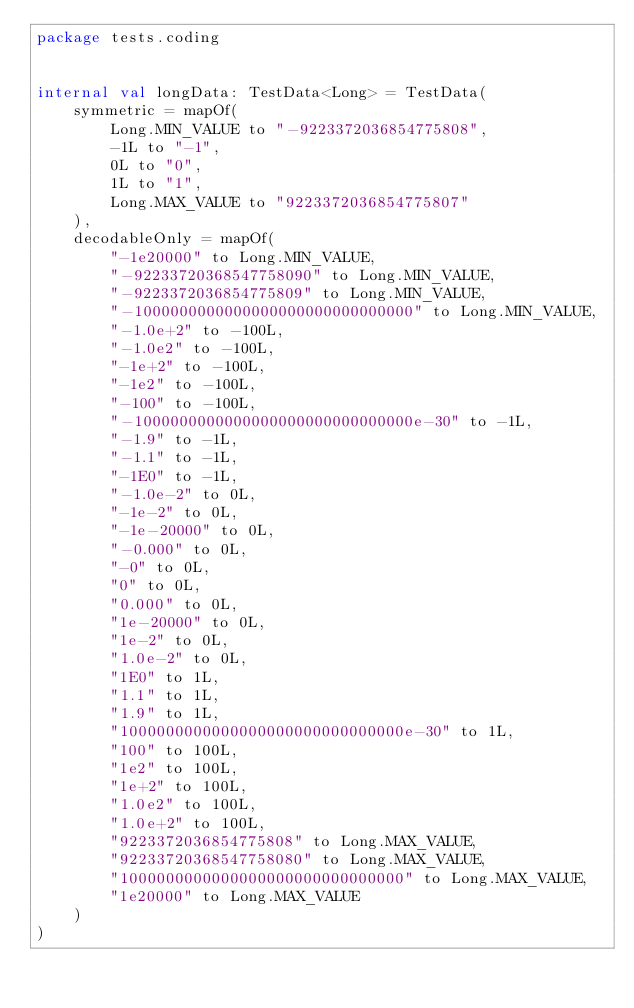Convert code to text. <code><loc_0><loc_0><loc_500><loc_500><_Kotlin_>package tests.coding


internal val longData: TestData<Long> = TestData(
	symmetric = mapOf(
		Long.MIN_VALUE to "-9223372036854775808",
		-1L to "-1",
		0L to "0",
		1L to "1",
		Long.MAX_VALUE to "9223372036854775807"
	),
	decodableOnly = mapOf(
		"-1e20000" to Long.MIN_VALUE,
		"-92233720368547758090" to Long.MIN_VALUE,
		"-9223372036854775809" to Long.MIN_VALUE,
		"-1000000000000000000000000000000" to Long.MIN_VALUE,
		"-1.0e+2" to -100L,
		"-1.0e2" to -100L,
		"-1e+2" to -100L,
		"-1e2" to -100L,
		"-100" to -100L,
		"-1000000000000000000000000000000e-30" to -1L,
		"-1.9" to -1L,
		"-1.1" to -1L,
		"-1E0" to -1L,
		"-1.0e-2" to 0L,
		"-1e-2" to 0L,
		"-1e-20000" to 0L,
		"-0.000" to 0L,
		"-0" to 0L,
		"0" to 0L,
		"0.000" to 0L,
		"1e-20000" to 0L,
		"1e-2" to 0L,
		"1.0e-2" to 0L,
		"1E0" to 1L,
		"1.1" to 1L,
		"1.9" to 1L,
		"1000000000000000000000000000000e-30" to 1L,
		"100" to 100L,
		"1e2" to 100L,
		"1e+2" to 100L,
		"1.0e2" to 100L,
		"1.0e+2" to 100L,
		"9223372036854775808" to Long.MAX_VALUE,
		"92233720368547758080" to Long.MAX_VALUE,
		"1000000000000000000000000000000" to Long.MAX_VALUE,
		"1e20000" to Long.MAX_VALUE
	)
)
</code> 